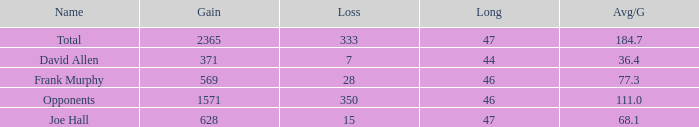How much Avg/G has a Gain smaller than 1571, and a Long smaller than 46? 1.0. 